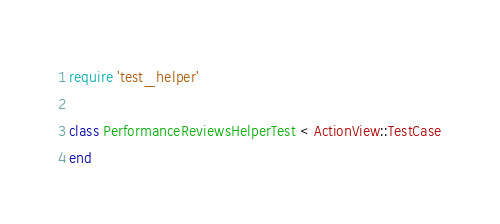<code> <loc_0><loc_0><loc_500><loc_500><_Ruby_>require 'test_helper'

class PerformanceReviewsHelperTest < ActionView::TestCase
end
</code> 